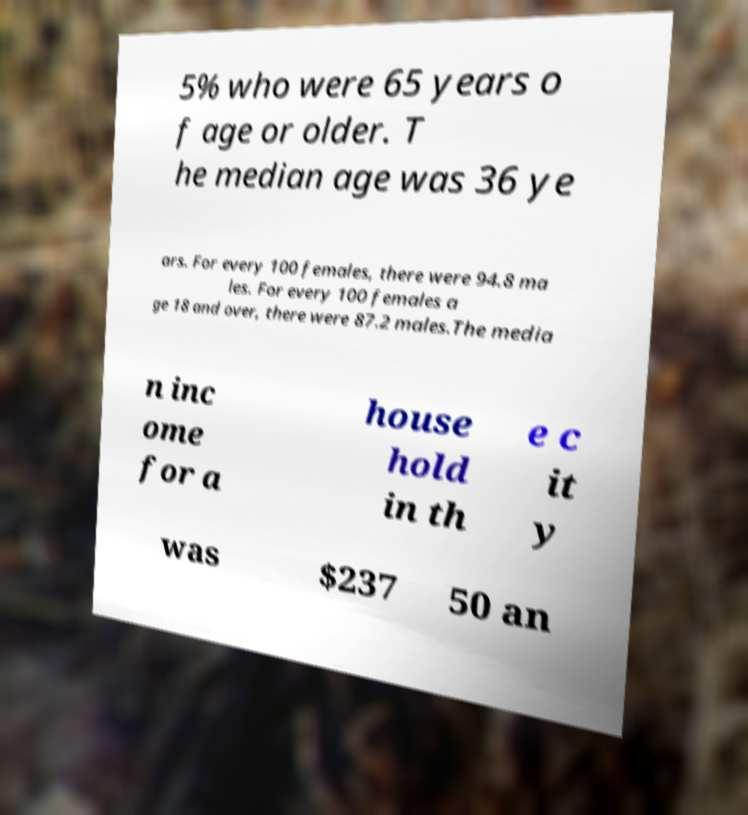Can you accurately transcribe the text from the provided image for me? 5% who were 65 years o f age or older. T he median age was 36 ye ars. For every 100 females, there were 94.8 ma les. For every 100 females a ge 18 and over, there were 87.2 males.The media n inc ome for a house hold in th e c it y was $237 50 an 